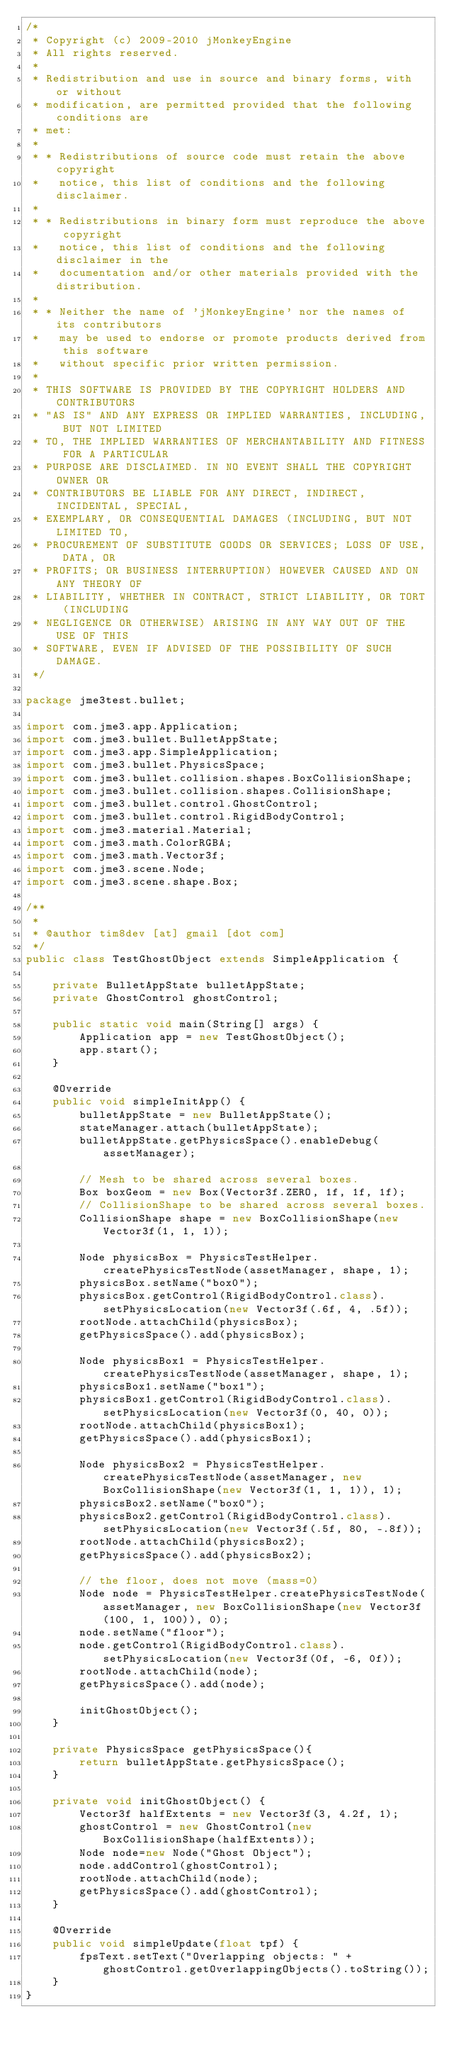<code> <loc_0><loc_0><loc_500><loc_500><_Java_>/*
 * Copyright (c) 2009-2010 jMonkeyEngine
 * All rights reserved.
 *
 * Redistribution and use in source and binary forms, with or without
 * modification, are permitted provided that the following conditions are
 * met:
 *
 * * Redistributions of source code must retain the above copyright
 *   notice, this list of conditions and the following disclaimer.
 *
 * * Redistributions in binary form must reproduce the above copyright
 *   notice, this list of conditions and the following disclaimer in the
 *   documentation and/or other materials provided with the distribution.
 *
 * * Neither the name of 'jMonkeyEngine' nor the names of its contributors
 *   may be used to endorse or promote products derived from this software
 *   without specific prior written permission.
 *
 * THIS SOFTWARE IS PROVIDED BY THE COPYRIGHT HOLDERS AND CONTRIBUTORS
 * "AS IS" AND ANY EXPRESS OR IMPLIED WARRANTIES, INCLUDING, BUT NOT LIMITED
 * TO, THE IMPLIED WARRANTIES OF MERCHANTABILITY AND FITNESS FOR A PARTICULAR
 * PURPOSE ARE DISCLAIMED. IN NO EVENT SHALL THE COPYRIGHT OWNER OR
 * CONTRIBUTORS BE LIABLE FOR ANY DIRECT, INDIRECT, INCIDENTAL, SPECIAL,
 * EXEMPLARY, OR CONSEQUENTIAL DAMAGES (INCLUDING, BUT NOT LIMITED TO,
 * PROCUREMENT OF SUBSTITUTE GOODS OR SERVICES; LOSS OF USE, DATA, OR
 * PROFITS; OR BUSINESS INTERRUPTION) HOWEVER CAUSED AND ON ANY THEORY OF
 * LIABILITY, WHETHER IN CONTRACT, STRICT LIABILITY, OR TORT (INCLUDING
 * NEGLIGENCE OR OTHERWISE) ARISING IN ANY WAY OUT OF THE USE OF THIS
 * SOFTWARE, EVEN IF ADVISED OF THE POSSIBILITY OF SUCH DAMAGE.
 */

package jme3test.bullet;

import com.jme3.app.Application;
import com.jme3.bullet.BulletAppState;
import com.jme3.app.SimpleApplication;
import com.jme3.bullet.PhysicsSpace;
import com.jme3.bullet.collision.shapes.BoxCollisionShape;
import com.jme3.bullet.collision.shapes.CollisionShape;
import com.jme3.bullet.control.GhostControl;
import com.jme3.bullet.control.RigidBodyControl;
import com.jme3.material.Material;
import com.jme3.math.ColorRGBA;
import com.jme3.math.Vector3f;
import com.jme3.scene.Node;
import com.jme3.scene.shape.Box;

/**
 *
 * @author tim8dev [at] gmail [dot com]
 */
public class TestGhostObject extends SimpleApplication {

    private BulletAppState bulletAppState;
    private GhostControl ghostControl;

    public static void main(String[] args) {
        Application app = new TestGhostObject();
        app.start();
    }

    @Override
    public void simpleInitApp() {
        bulletAppState = new BulletAppState();
        stateManager.attach(bulletAppState);
        bulletAppState.getPhysicsSpace().enableDebug(assetManager);

        // Mesh to be shared across several boxes.
        Box boxGeom = new Box(Vector3f.ZERO, 1f, 1f, 1f);
        // CollisionShape to be shared across several boxes.
        CollisionShape shape = new BoxCollisionShape(new Vector3f(1, 1, 1));

        Node physicsBox = PhysicsTestHelper.createPhysicsTestNode(assetManager, shape, 1);
        physicsBox.setName("box0");
        physicsBox.getControl(RigidBodyControl.class).setPhysicsLocation(new Vector3f(.6f, 4, .5f));
        rootNode.attachChild(physicsBox);
        getPhysicsSpace().add(physicsBox);

        Node physicsBox1 = PhysicsTestHelper.createPhysicsTestNode(assetManager, shape, 1);
        physicsBox1.setName("box1");
        physicsBox1.getControl(RigidBodyControl.class).setPhysicsLocation(new Vector3f(0, 40, 0));
        rootNode.attachChild(physicsBox1);
        getPhysicsSpace().add(physicsBox1);

        Node physicsBox2 = PhysicsTestHelper.createPhysicsTestNode(assetManager, new BoxCollisionShape(new Vector3f(1, 1, 1)), 1);
        physicsBox2.setName("box0");
        physicsBox2.getControl(RigidBodyControl.class).setPhysicsLocation(new Vector3f(.5f, 80, -.8f));
        rootNode.attachChild(physicsBox2);
        getPhysicsSpace().add(physicsBox2);

        // the floor, does not move (mass=0)
        Node node = PhysicsTestHelper.createPhysicsTestNode(assetManager, new BoxCollisionShape(new Vector3f(100, 1, 100)), 0);
        node.setName("floor");
        node.getControl(RigidBodyControl.class).setPhysicsLocation(new Vector3f(0f, -6, 0f));
        rootNode.attachChild(node);
        getPhysicsSpace().add(node);

        initGhostObject();
    }

    private PhysicsSpace getPhysicsSpace(){
        return bulletAppState.getPhysicsSpace();
    }

    private void initGhostObject() {
        Vector3f halfExtents = new Vector3f(3, 4.2f, 1);
        ghostControl = new GhostControl(new BoxCollisionShape(halfExtents));
        Node node=new Node("Ghost Object");
        node.addControl(ghostControl);
        rootNode.attachChild(node);
        getPhysicsSpace().add(ghostControl);
    }

    @Override
    public void simpleUpdate(float tpf) {
        fpsText.setText("Overlapping objects: " + ghostControl.getOverlappingObjects().toString());
    }
}
</code> 